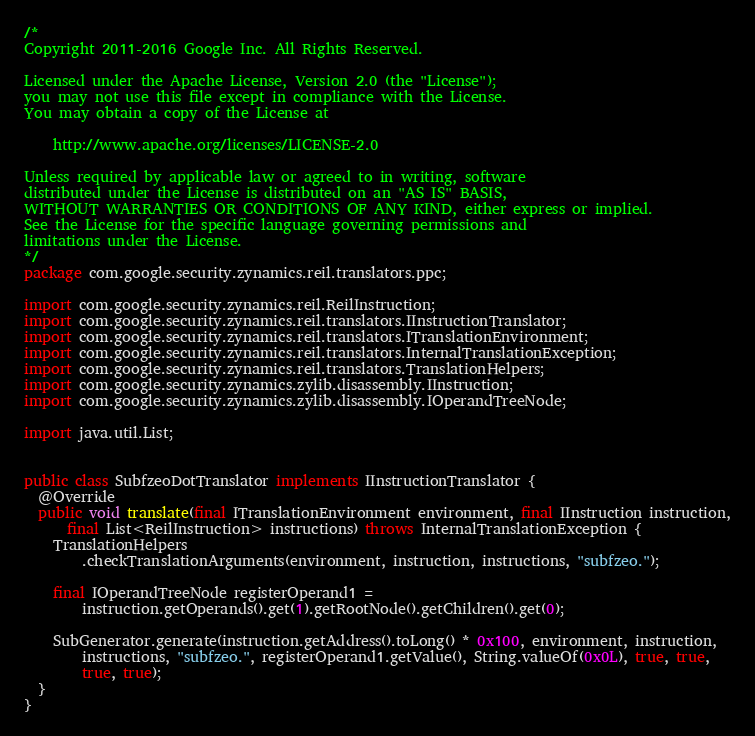<code> <loc_0><loc_0><loc_500><loc_500><_Java_>/*
Copyright 2011-2016 Google Inc. All Rights Reserved.

Licensed under the Apache License, Version 2.0 (the "License");
you may not use this file except in compliance with the License.
You may obtain a copy of the License at

    http://www.apache.org/licenses/LICENSE-2.0

Unless required by applicable law or agreed to in writing, software
distributed under the License is distributed on an "AS IS" BASIS,
WITHOUT WARRANTIES OR CONDITIONS OF ANY KIND, either express or implied.
See the License for the specific language governing permissions and
limitations under the License.
*/
package com.google.security.zynamics.reil.translators.ppc;

import com.google.security.zynamics.reil.ReilInstruction;
import com.google.security.zynamics.reil.translators.IInstructionTranslator;
import com.google.security.zynamics.reil.translators.ITranslationEnvironment;
import com.google.security.zynamics.reil.translators.InternalTranslationException;
import com.google.security.zynamics.reil.translators.TranslationHelpers;
import com.google.security.zynamics.zylib.disassembly.IInstruction;
import com.google.security.zynamics.zylib.disassembly.IOperandTreeNode;

import java.util.List;


public class SubfzeoDotTranslator implements IInstructionTranslator {
  @Override
  public void translate(final ITranslationEnvironment environment, final IInstruction instruction,
      final List<ReilInstruction> instructions) throws InternalTranslationException {
    TranslationHelpers
        .checkTranslationArguments(environment, instruction, instructions, "subfzeo.");

    final IOperandTreeNode registerOperand1 =
        instruction.getOperands().get(1).getRootNode().getChildren().get(0);

    SubGenerator.generate(instruction.getAddress().toLong() * 0x100, environment, instruction,
        instructions, "subfzeo.", registerOperand1.getValue(), String.valueOf(0x0L), true, true,
        true, true);
  }
}
</code> 